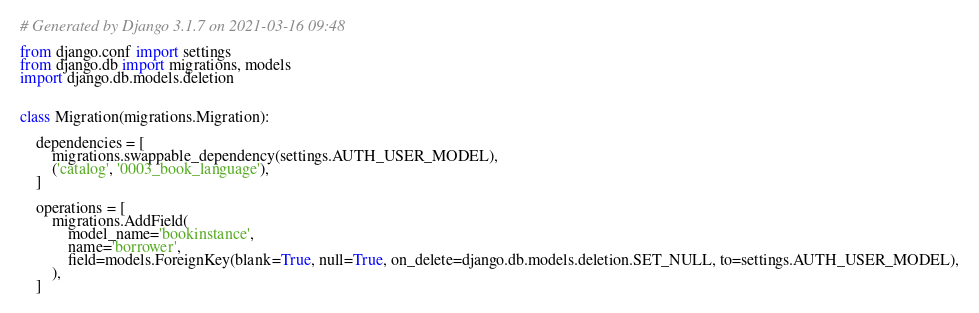Convert code to text. <code><loc_0><loc_0><loc_500><loc_500><_Python_># Generated by Django 3.1.7 on 2021-03-16 09:48

from django.conf import settings
from django.db import migrations, models
import django.db.models.deletion


class Migration(migrations.Migration):

    dependencies = [
        migrations.swappable_dependency(settings.AUTH_USER_MODEL),
        ('catalog', '0003_book_language'),
    ]

    operations = [
        migrations.AddField(
            model_name='bookinstance',
            name='borrower',
            field=models.ForeignKey(blank=True, null=True, on_delete=django.db.models.deletion.SET_NULL, to=settings.AUTH_USER_MODEL),
        ),
    ]
</code> 